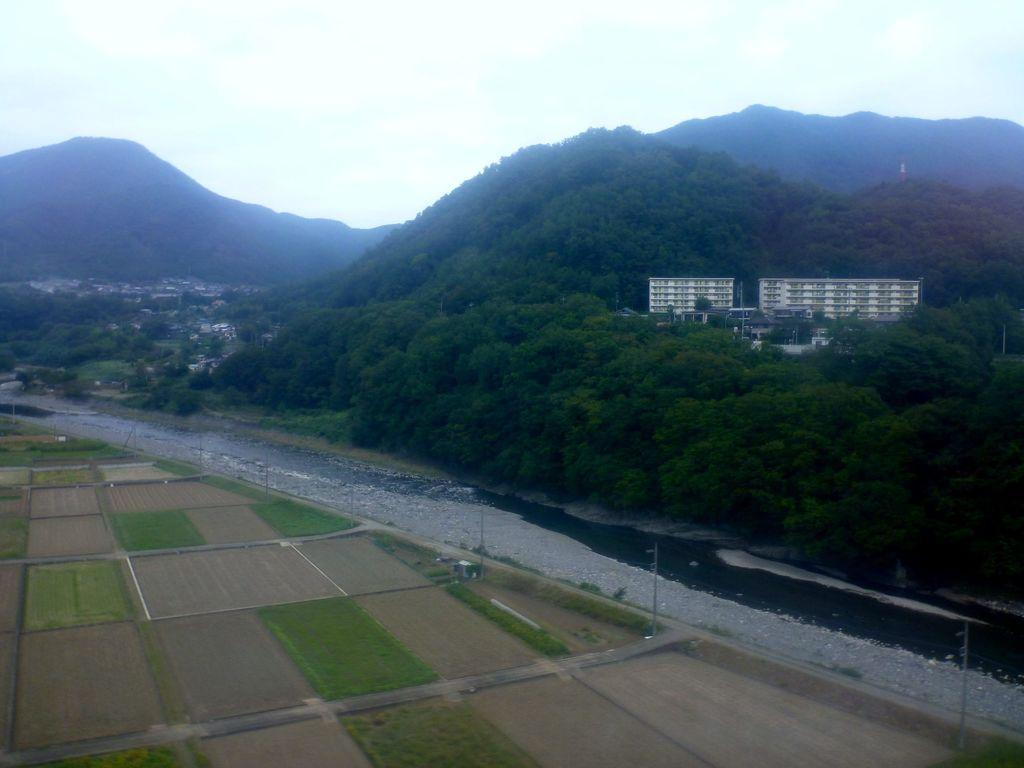What structure is located on the right side of the image? There is a building on the right side of the image. What is at the bottom of the image? There is a road at the bottom of the image. What type of landscape is visible in the image? Fields are visible in the image. What can be seen in the background of the image? There are hills and the sky visible in the background of the image. Where is the sack of potatoes located in the image? There is no sack of potatoes present in the image. Is there a girl visible in the image? There is no girl present in the image. 